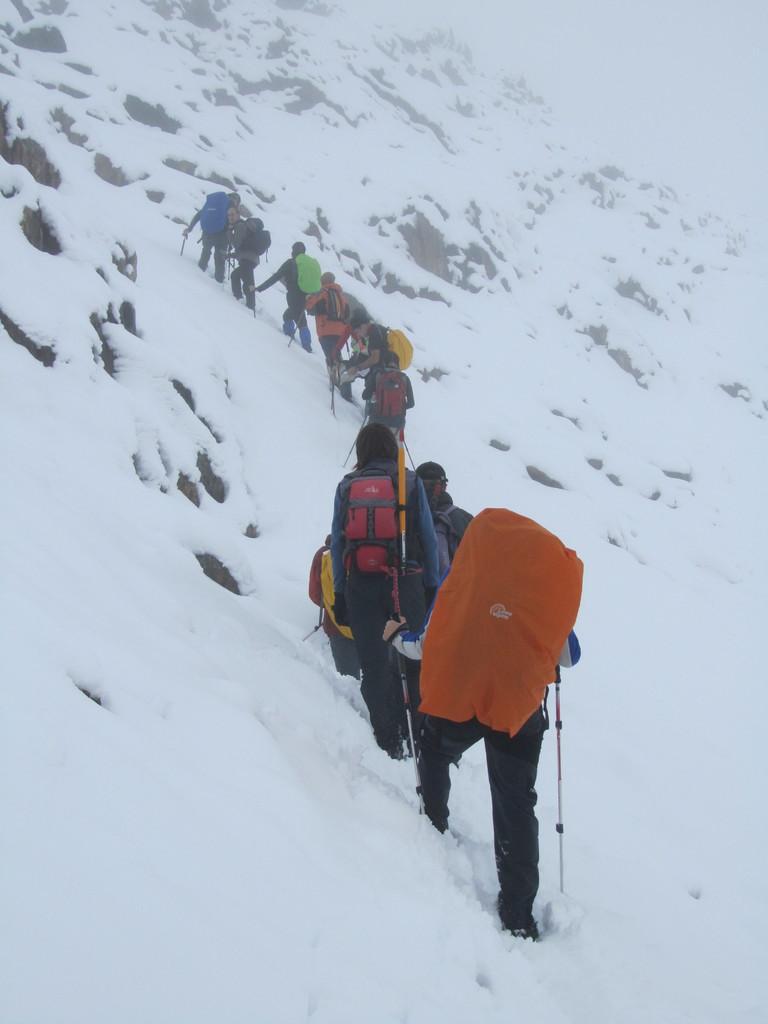Can you describe this image briefly? In the picture I can see these people wearing sweaters are carrying backpacks and holding the skis in their hands and walking on the snow and here I can see the fog in the background. 